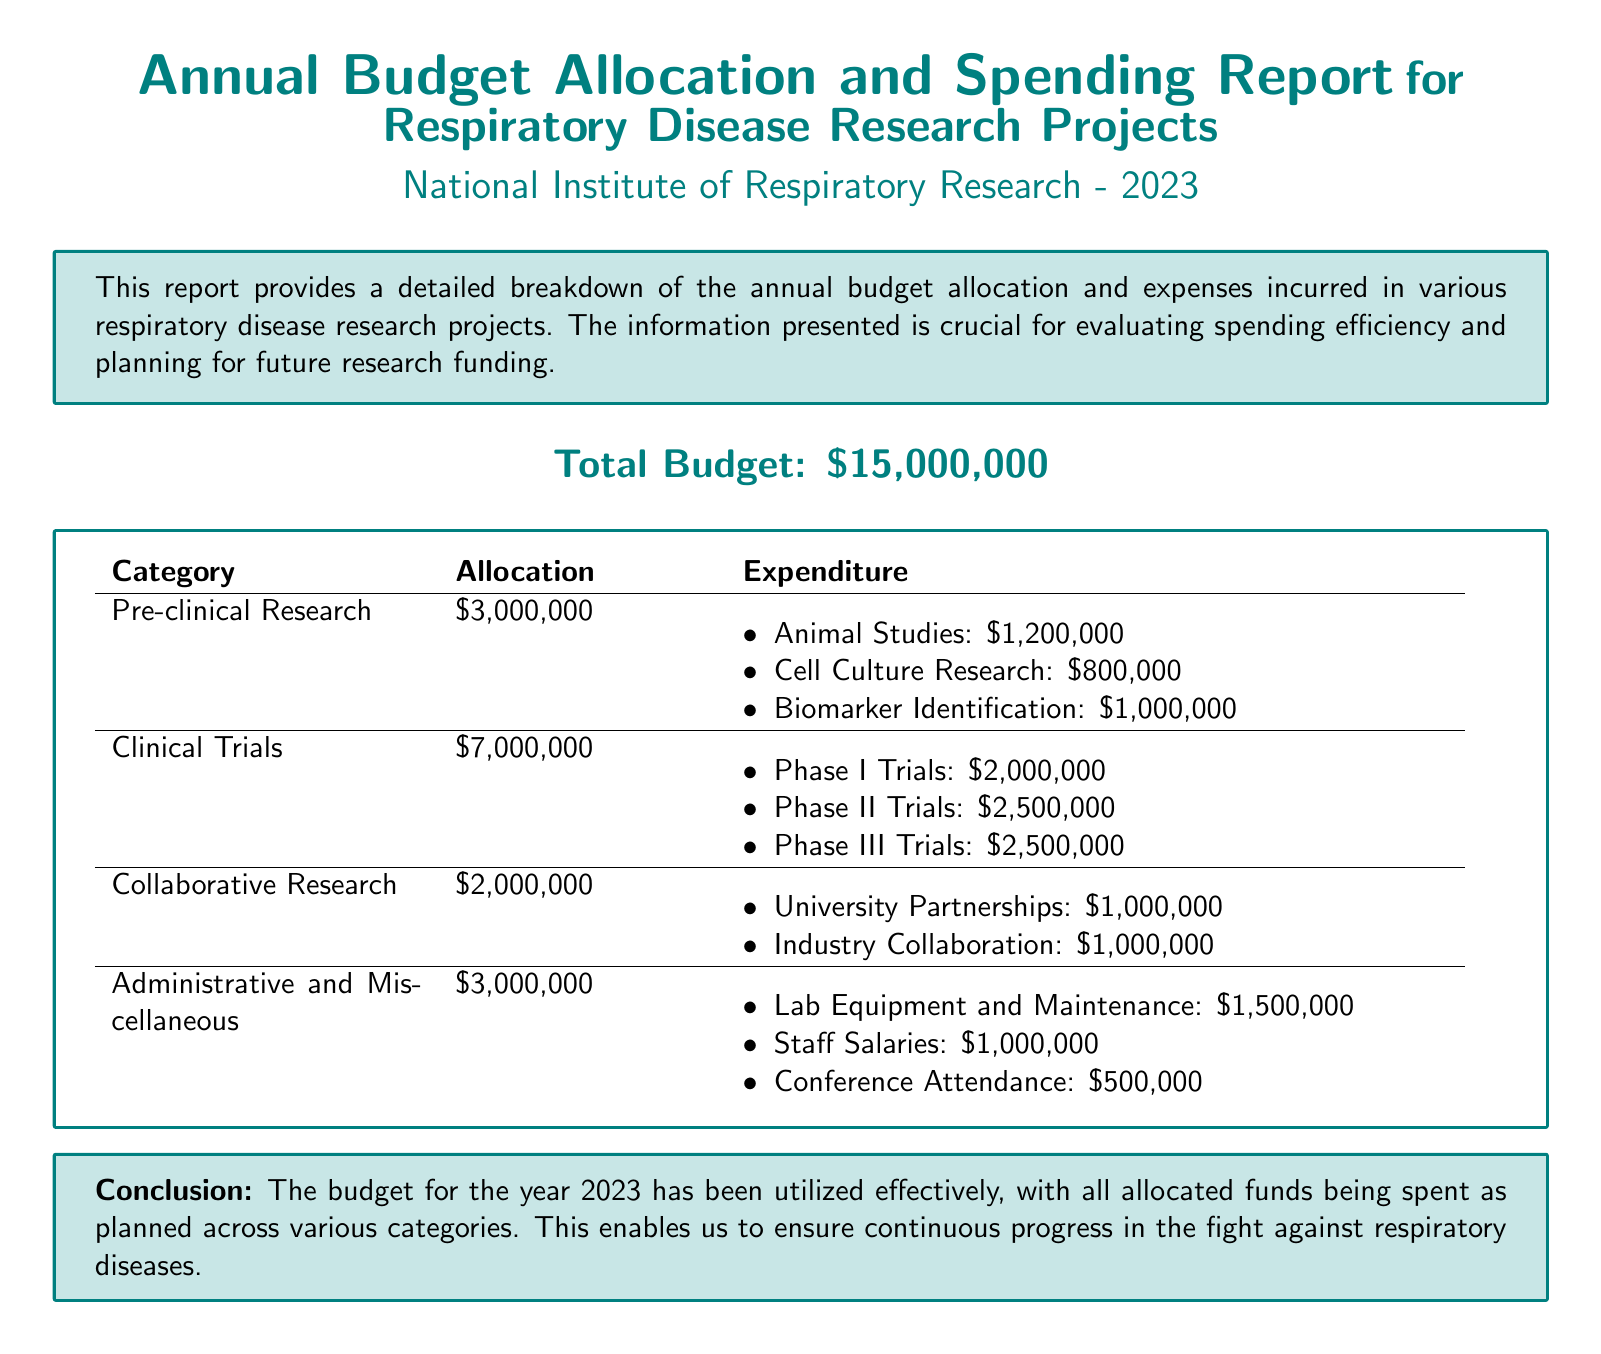What is the total budget? The total budget is stated at the beginning of the report as $15,000,000.
Answer: $15,000,000 How much was allocated for Clinical Trials? The allocation for Clinical Trials is provided in the document, which is $7,000,000.
Answer: $7,000,000 What is the expenditure on Phase II Trials? The expenditure for Phase II Trials is detailed in the Clinical Trials category as $2,500,000.
Answer: $2,500,000 What amount was spent on Staff Salaries? Staff Salaries expenditure is mentioned under Administrative and Miscellaneous, totaling $1,000,000.
Answer: $1,000,000 What is the total allocation for Pre-clinical Research? The total allocation for Pre-clinical Research can be found in the document as $3,000,000.
Answer: $3,000,000 How much was spent on Biomarker Identification? The document indicates that $1,000,000 was spent on Biomarker Identification under Pre-clinical Research.
Answer: $1,000,000 Which category had the highest expenditure? Clinical Trials had the highest expenditure, with a total of $7,000,000 spent.
Answer: Clinical Trials What portion of the total budget is allocated for Administrative and Miscellaneous? The allocation for Administrative and Miscellaneous is stated as $3,000,000, which is part of the total budget.
Answer: $3,000,000 What is the main conclusion of the report? The main conclusion summarizing the budget utilization is that the funds were effectively spent as planned.
Answer: Effectively utilized What is the total expenditure for Collaborative Research? The document specifies that the total expenditure for Collaborative Research is $2,000,000.
Answer: $2,000,000 